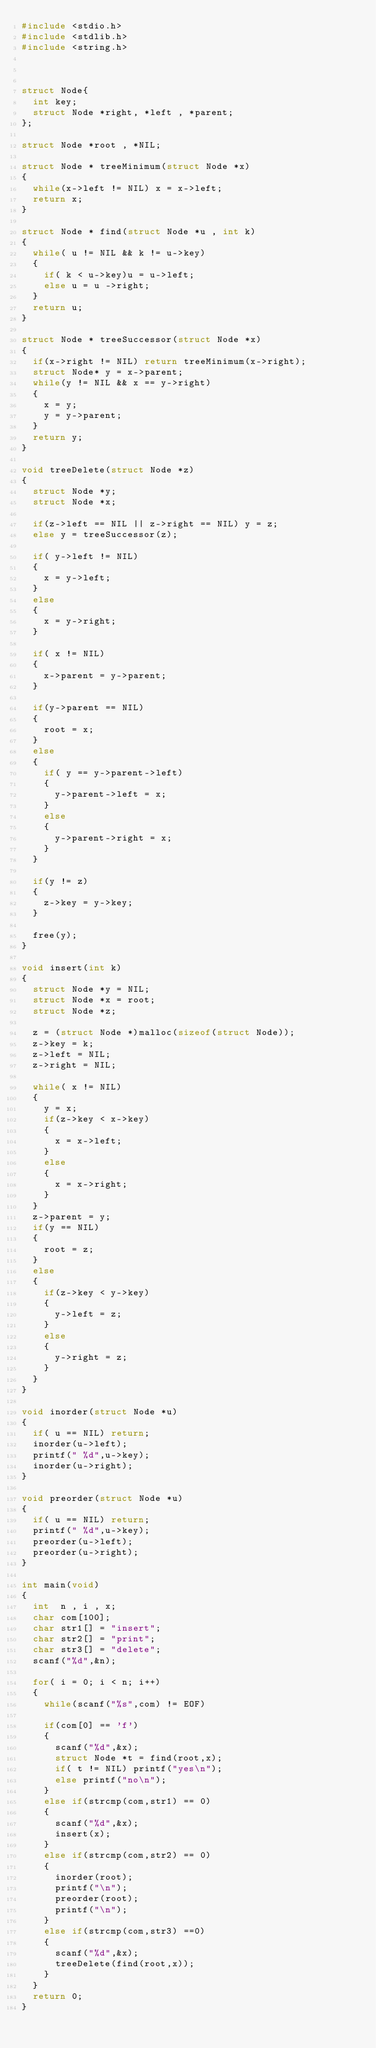Convert code to text. <code><loc_0><loc_0><loc_500><loc_500><_C_>#include <stdio.h>
#include <stdlib.h>
#include <string.h>



struct Node{
	int key;
	struct Node *right, *left , *parent;
};

struct Node *root , *NIL;

struct Node * treeMinimum(struct Node *x)
{
	while(x->left != NIL) x = x->left;
	return x;
}

struct Node * find(struct Node *u , int k)
{
	while( u != NIL && k != u->key)
	{
		if( k < u->key)u = u->left;
		else u = u ->right;
	}
	return u;
}

struct Node * treeSuccessor(struct Node *x)
{
	if(x->right != NIL) return treeMinimum(x->right);
	struct Node* y = x->parent;
	while(y != NIL && x == y->right)
	{
		x = y;
		y = y->parent;
	}
	return y;
}

void treeDelete(struct Node *z)
{
	struct Node *y;
	struct Node *x;
	
	if(z->left == NIL || z->right == NIL) y = z;
	else y = treeSuccessor(z);
	
	if( y->left != NIL)
	{
		x = y->left;
	}
	else
	{
		x = y->right;
	}
	
	if( x != NIL)
	{
		x->parent = y->parent;
	}
	
	if(y->parent == NIL)
	{
		root = x;
	}
	else
	{
		if( y == y->parent->left)
		{
			y->parent->left = x;
		}
		else
		{
			y->parent->right = x;
		}
	}
	
	if(y != z)
	{
		z->key = y->key;
	}
	
	free(y);
}	

void insert(int k)
{
	struct Node *y = NIL;
	struct Node *x = root;
	struct Node *z;
	
	z = (struct Node *)malloc(sizeof(struct Node));
	z->key = k;
	z->left = NIL;
	z->right = NIL;
	
	while( x != NIL)
	{
		y = x;
		if(z->key < x->key)
		{
			x = x->left;
		}
		else
		{
			x = x->right;
		}
	}
	z->parent = y;
	if(y == NIL)
	{
		root = z;
	}
	else
	{
		if(z->key < y->key)
		{
			y->left = z;
		}
		else
		{
			y->right = z;
		}
	}
}

void inorder(struct Node *u)
{
	if( u == NIL) return;
	inorder(u->left);
	printf(" %d",u->key);
	inorder(u->right);
}

void preorder(struct Node *u)
{
	if( u == NIL) return;
	printf(" %d",u->key);
	preorder(u->left);
	preorder(u->right);
}

int main(void)
{
	int  n , i , x;
	char com[100];
	char str1[] = "insert";
	char str2[] = "print";
	char str3[] = "delete";
	scanf("%d",&n);
	
	for( i = 0; i < n; i++)
	{
		while(scanf("%s",com) != EOF)
		
		if(com[0] == 'f')
		{
			scanf("%d",&x);
			struct Node *t = find(root,x);
			if( t != NIL) printf("yes\n");
			else printf("no\n");
		}
		else if(strcmp(com,str1) == 0)
		{
			scanf("%d",&x);
			insert(x);
		}
		else if(strcmp(com,str2) == 0)
		{
			inorder(root);
			printf("\n");
			preorder(root);
			printf("\n");
		}
		else if(strcmp(com,str3) ==0)
		{
			scanf("%d",&x);
			treeDelete(find(root,x));
		}
	}
	return 0;
}

</code> 